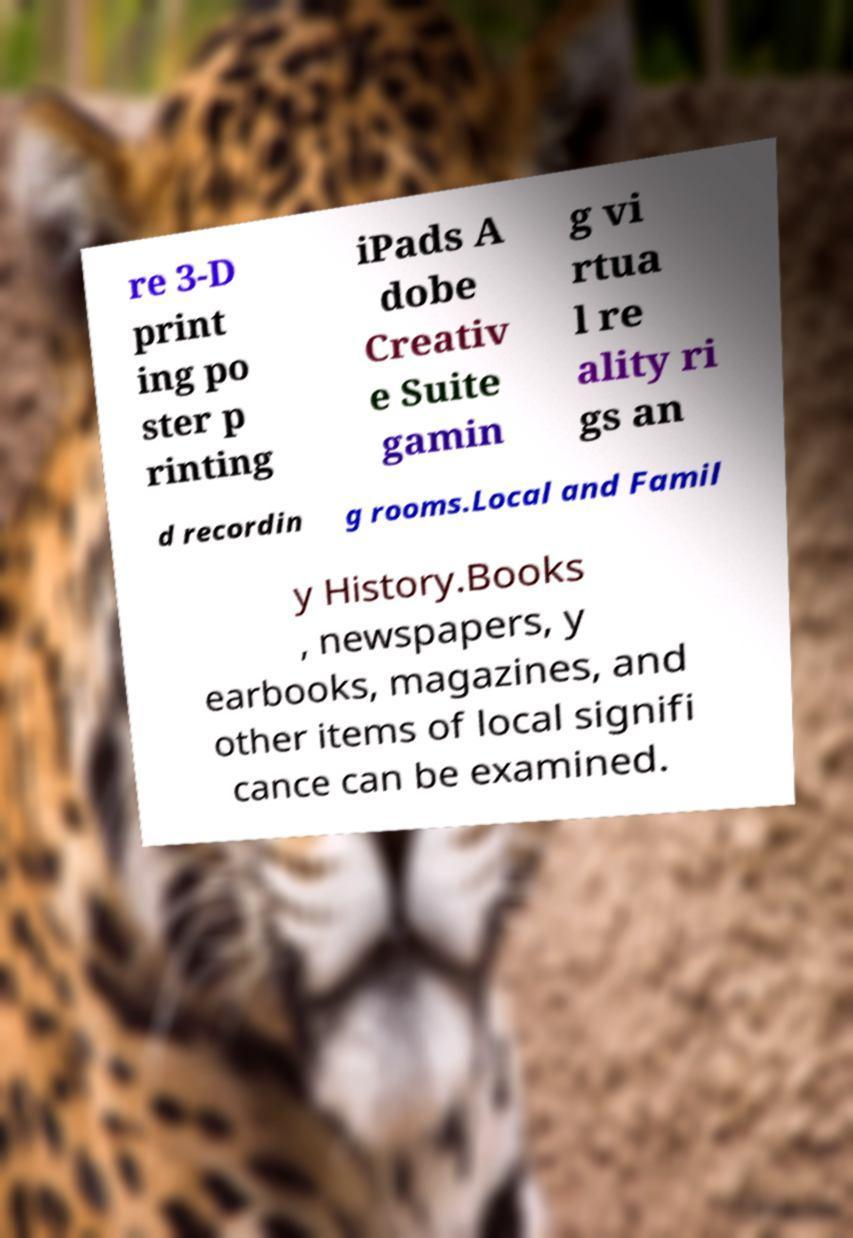Can you read and provide the text displayed in the image?This photo seems to have some interesting text. Can you extract and type it out for me? re 3-D print ing po ster p rinting iPads A dobe Creativ e Suite gamin g vi rtua l re ality ri gs an d recordin g rooms.Local and Famil y History.Books , newspapers, y earbooks, magazines, and other items of local signifi cance can be examined. 